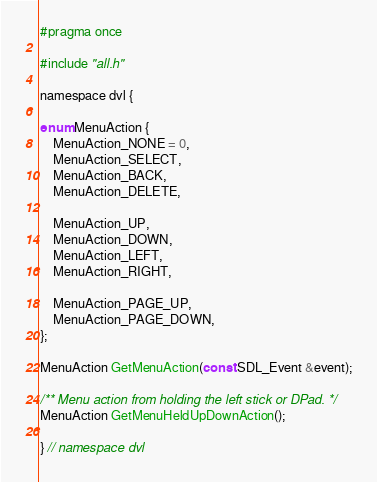Convert code to text. <code><loc_0><loc_0><loc_500><loc_500><_C_>#pragma once

#include "all.h"

namespace dvl {

enum MenuAction {
	MenuAction_NONE = 0,
	MenuAction_SELECT,
	MenuAction_BACK,
	MenuAction_DELETE,

	MenuAction_UP,
	MenuAction_DOWN,
	MenuAction_LEFT,
	MenuAction_RIGHT,

	MenuAction_PAGE_UP,
	MenuAction_PAGE_DOWN,
};

MenuAction GetMenuAction(const SDL_Event &event);

/** Menu action from holding the left stick or DPad. */
MenuAction GetMenuHeldUpDownAction();

} // namespace dvl
</code> 